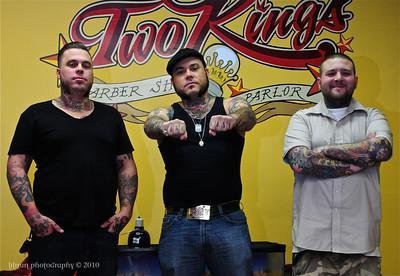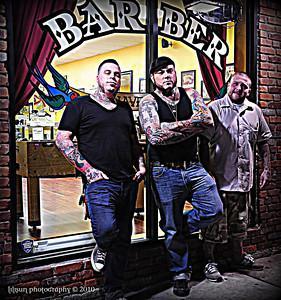The first image is the image on the left, the second image is the image on the right. Assess this claim about the two images: "An image shows just one young male customer with upswept hair.". Correct or not? Answer yes or no. No. The first image is the image on the left, the second image is the image on the right. For the images shown, is this caption "There is at least one empty chair shown." true? Answer yes or no. No. 